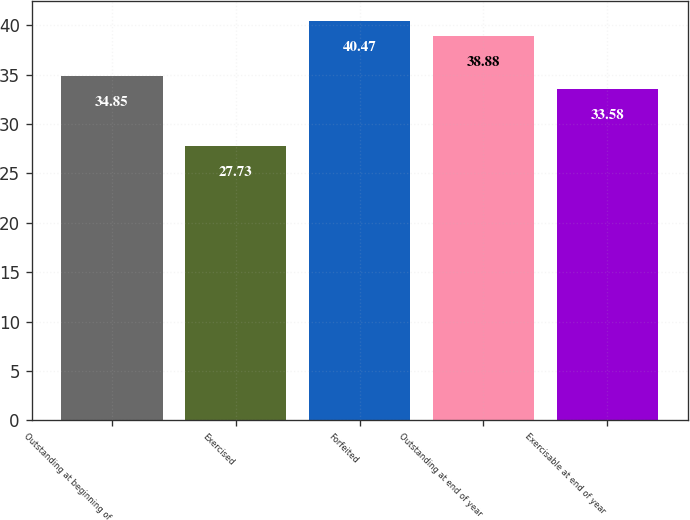<chart> <loc_0><loc_0><loc_500><loc_500><bar_chart><fcel>Outstanding at beginning of<fcel>Exercised<fcel>Forfeited<fcel>Outstanding at end of year<fcel>Exercisable at end of year<nl><fcel>34.85<fcel>27.73<fcel>40.47<fcel>38.88<fcel>33.58<nl></chart> 